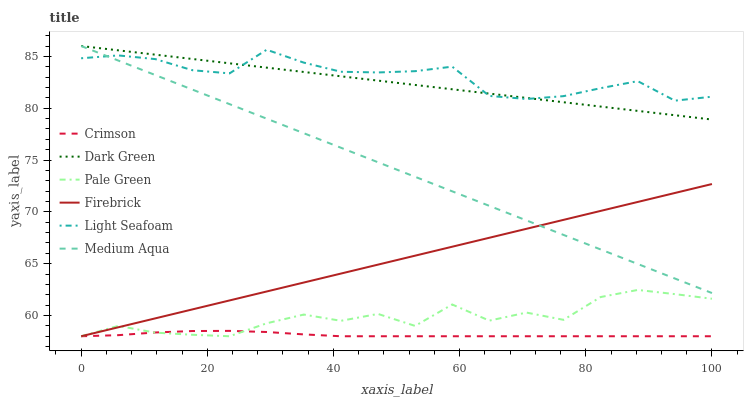Does Crimson have the minimum area under the curve?
Answer yes or no. Yes. Does Light Seafoam have the maximum area under the curve?
Answer yes or no. Yes. Does Pale Green have the minimum area under the curve?
Answer yes or no. No. Does Pale Green have the maximum area under the curve?
Answer yes or no. No. Is Dark Green the smoothest?
Answer yes or no. Yes. Is Pale Green the roughest?
Answer yes or no. Yes. Is Medium Aqua the smoothest?
Answer yes or no. No. Is Medium Aqua the roughest?
Answer yes or no. No. Does Firebrick have the lowest value?
Answer yes or no. Yes. Does Medium Aqua have the lowest value?
Answer yes or no. No. Does Dark Green have the highest value?
Answer yes or no. Yes. Does Pale Green have the highest value?
Answer yes or no. No. Is Crimson less than Medium Aqua?
Answer yes or no. Yes. Is Medium Aqua greater than Crimson?
Answer yes or no. Yes. Does Dark Green intersect Medium Aqua?
Answer yes or no. Yes. Is Dark Green less than Medium Aqua?
Answer yes or no. No. Is Dark Green greater than Medium Aqua?
Answer yes or no. No. Does Crimson intersect Medium Aqua?
Answer yes or no. No. 